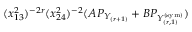Convert formula to latex. <formula><loc_0><loc_0><loc_500><loc_500>( x _ { 1 3 } ^ { 2 } ) ^ { - 2 r } ( x _ { 2 4 } ^ { 2 } ) ^ { - 2 } ( A P _ { Y _ { ( r + 1 ) } } + B P _ { Y _ { ( r , 1 ) } ^ { ( s y m ) } } )</formula> 